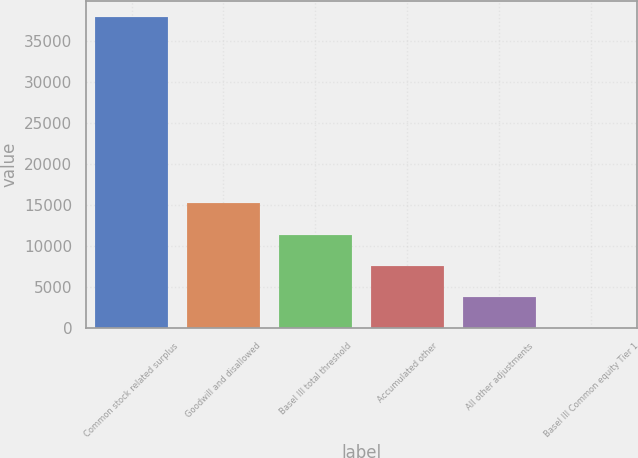Convert chart. <chart><loc_0><loc_0><loc_500><loc_500><bar_chart><fcel>Common stock related surplus<fcel>Goodwill and disallowed<fcel>Basel III total threshold<fcel>Accumulated other<fcel>All other adjustments<fcel>Basel III Common equity Tier 1<nl><fcel>38031<fcel>15218<fcel>11415.9<fcel>7613.72<fcel>3811.56<fcel>9.4<nl></chart> 